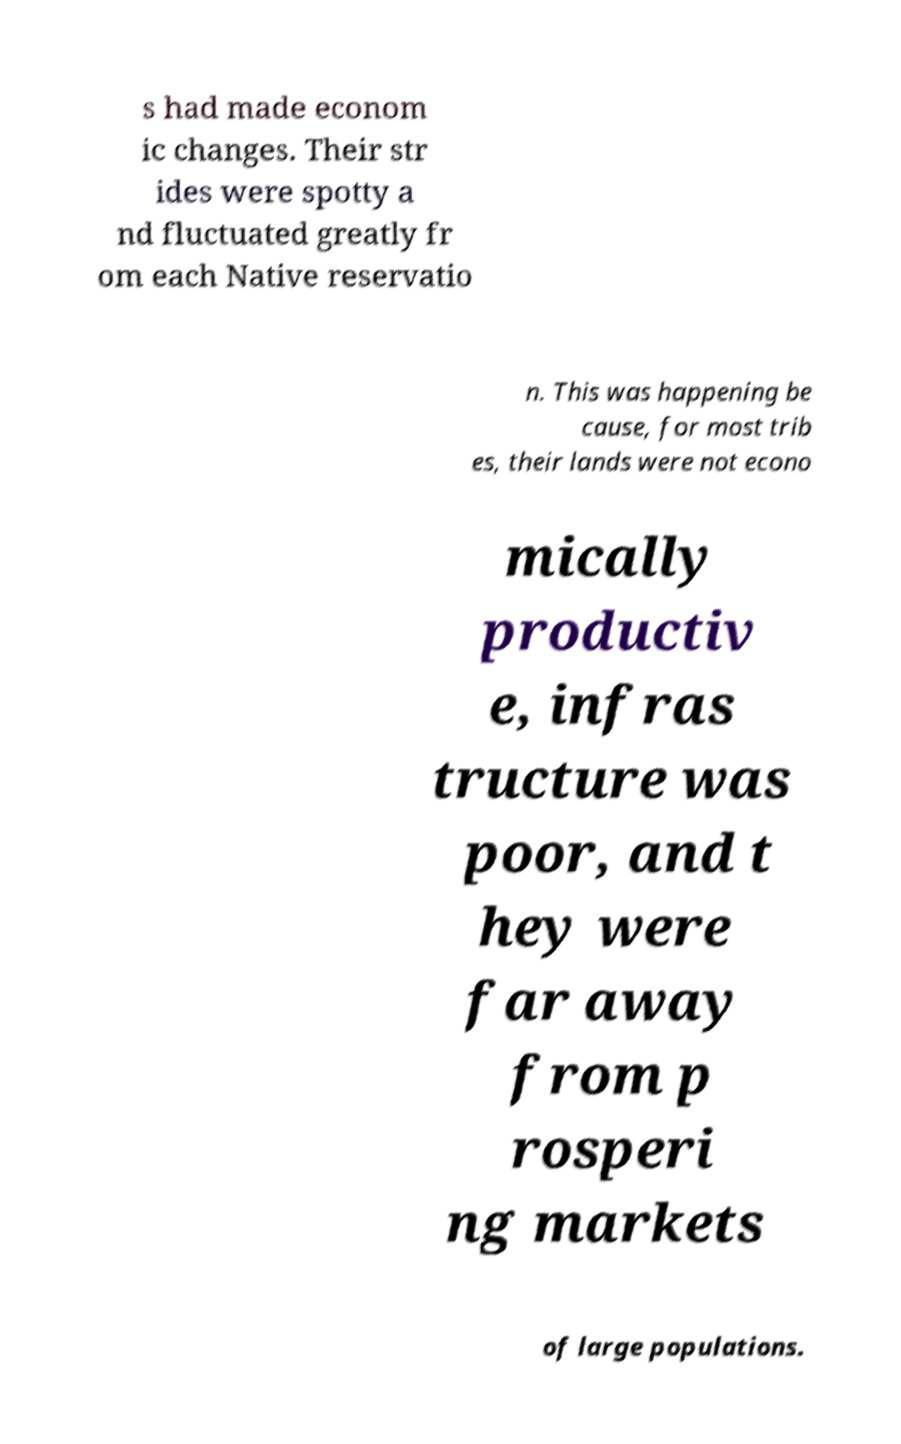What messages or text are displayed in this image? I need them in a readable, typed format. s had made econom ic changes. Their str ides were spotty a nd fluctuated greatly fr om each Native reservatio n. This was happening be cause, for most trib es, their lands were not econo mically productiv e, infras tructure was poor, and t hey were far away from p rosperi ng markets of large populations. 